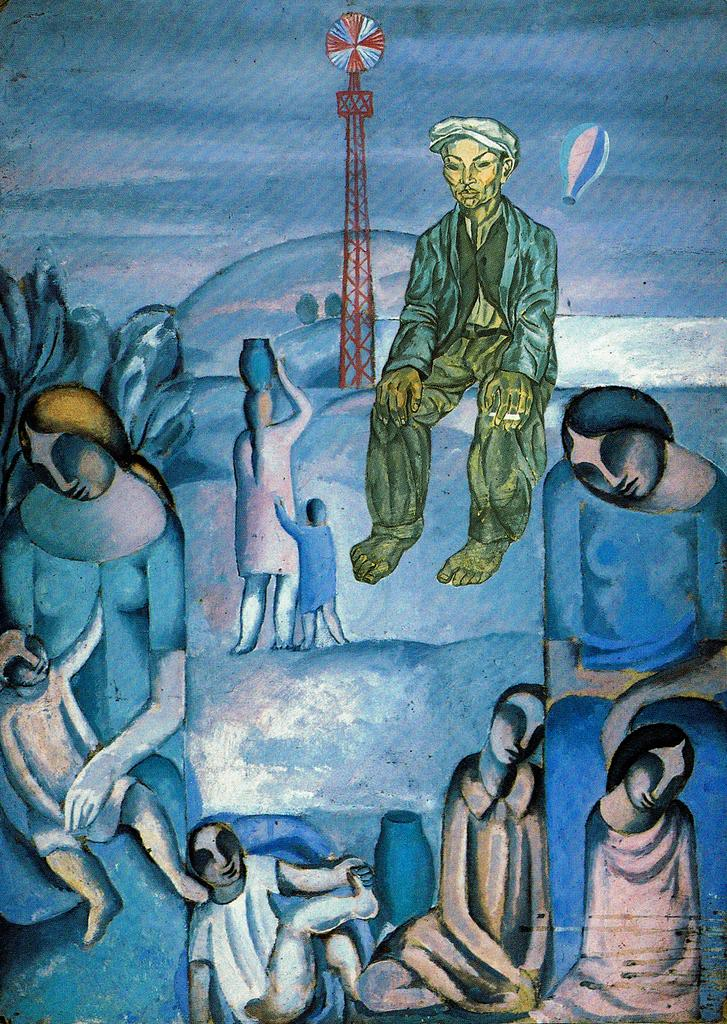What is the main subject of the image? The main subject of the image is a painting. What is depicted in the painting? The painting depicts people and a tower. What type of treatment is being administered to the people in the painting? There is no indication in the image that any treatment is being administered to the people in the painting. 